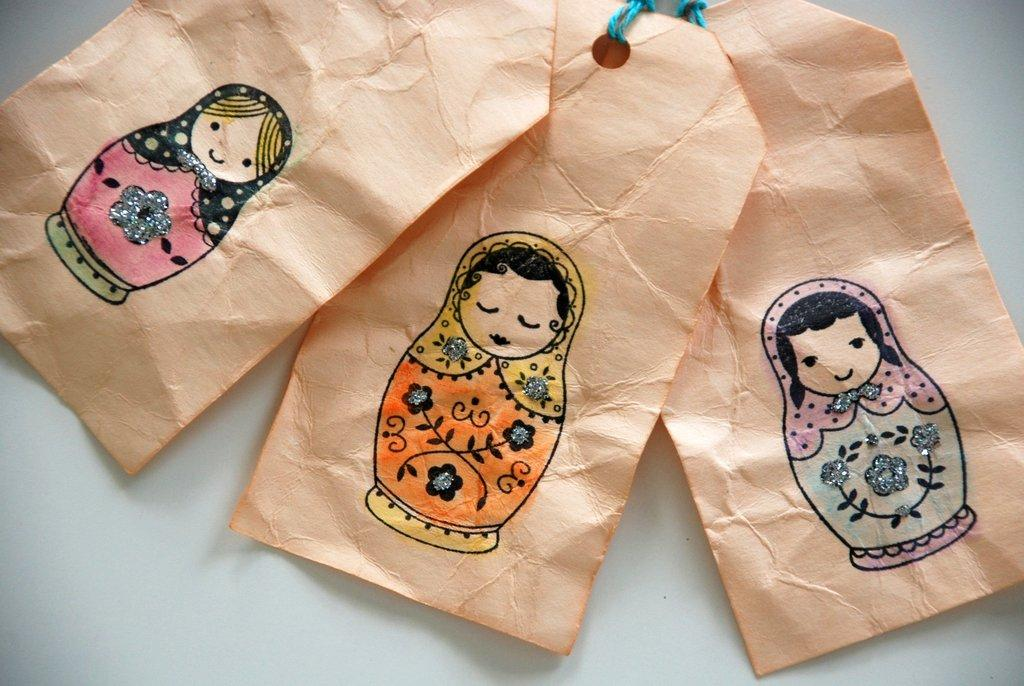What is the primary color of the surface in the image? The primary color of the surface in the image is white. How many tags are present on the white surface? There are three tags on the white surface. What is depicted on the tags? There is art on the tags. What type of material can be seen in the image? There are blue color threads visible in the image. How does the artist sort the impulse in the image? There is no artist or impulse present in the image; it only features a white surface with three tags and blue color threads. 